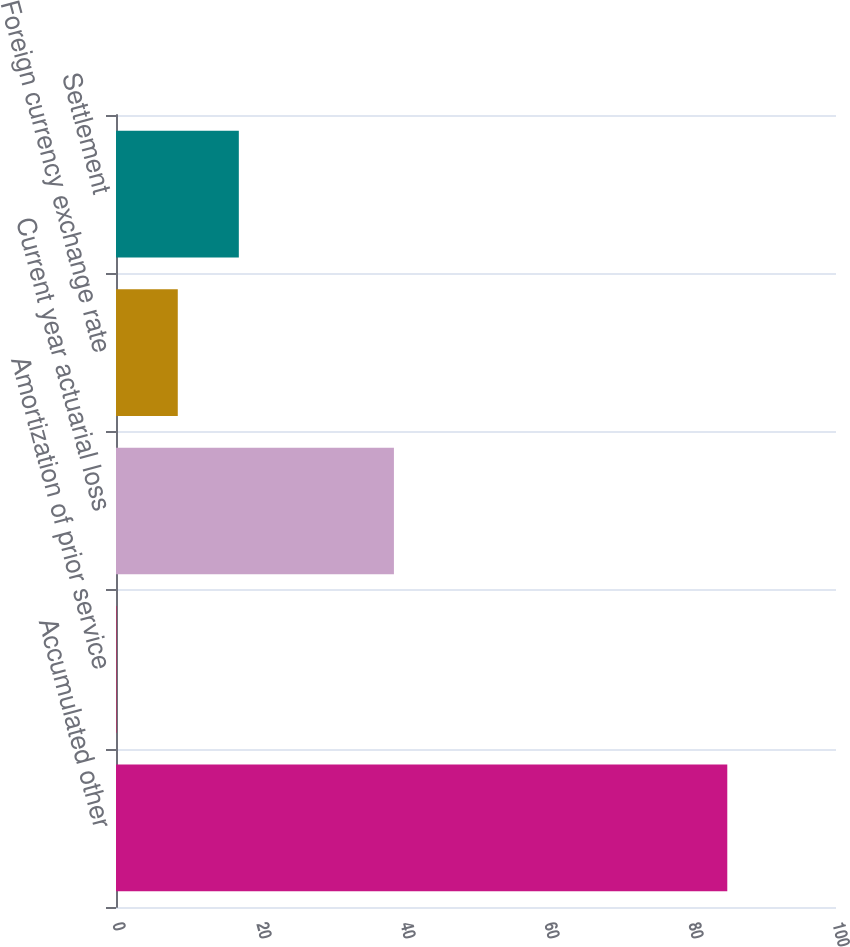Convert chart to OTSL. <chart><loc_0><loc_0><loc_500><loc_500><bar_chart><fcel>Accumulated other<fcel>Amortization of prior service<fcel>Current year actuarial loss<fcel>Foreign currency exchange rate<fcel>Settlement<nl><fcel>84.9<fcel>0.1<fcel>38.6<fcel>8.58<fcel>17.06<nl></chart> 